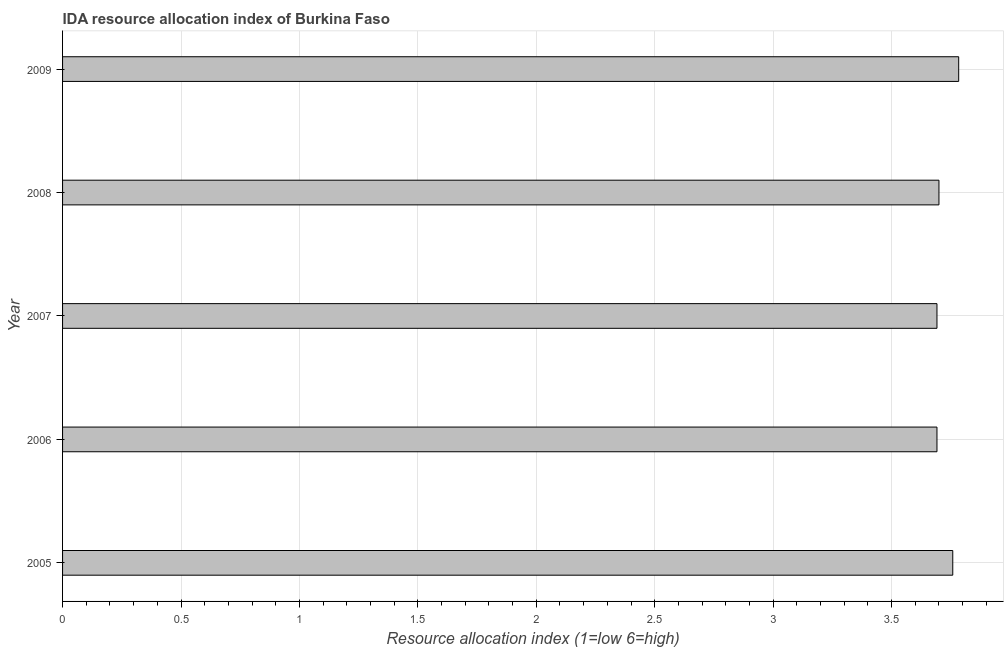Does the graph contain any zero values?
Ensure brevity in your answer.  No. What is the title of the graph?
Make the answer very short. IDA resource allocation index of Burkina Faso. What is the label or title of the X-axis?
Your response must be concise. Resource allocation index (1=low 6=high). What is the ida resource allocation index in 2008?
Keep it short and to the point. 3.7. Across all years, what is the maximum ida resource allocation index?
Offer a terse response. 3.78. Across all years, what is the minimum ida resource allocation index?
Give a very brief answer. 3.69. In which year was the ida resource allocation index minimum?
Your answer should be compact. 2006. What is the sum of the ida resource allocation index?
Give a very brief answer. 18.62. What is the difference between the ida resource allocation index in 2008 and 2009?
Provide a succinct answer. -0.08. What is the average ida resource allocation index per year?
Make the answer very short. 3.73. Do a majority of the years between 2008 and 2007 (inclusive) have ida resource allocation index greater than 3.7 ?
Your response must be concise. No. Is the ida resource allocation index in 2005 less than that in 2007?
Provide a succinct answer. No. Is the difference between the ida resource allocation index in 2006 and 2007 greater than the difference between any two years?
Provide a succinct answer. No. What is the difference between the highest and the second highest ida resource allocation index?
Make the answer very short. 0.03. Is the sum of the ida resource allocation index in 2007 and 2009 greater than the maximum ida resource allocation index across all years?
Your response must be concise. Yes. What is the difference between the highest and the lowest ida resource allocation index?
Provide a short and direct response. 0.09. In how many years, is the ida resource allocation index greater than the average ida resource allocation index taken over all years?
Ensure brevity in your answer.  2. What is the difference between two consecutive major ticks on the X-axis?
Your answer should be very brief. 0.5. Are the values on the major ticks of X-axis written in scientific E-notation?
Provide a succinct answer. No. What is the Resource allocation index (1=low 6=high) in 2005?
Your answer should be compact. 3.76. What is the Resource allocation index (1=low 6=high) of 2006?
Offer a terse response. 3.69. What is the Resource allocation index (1=low 6=high) in 2007?
Your answer should be very brief. 3.69. What is the Resource allocation index (1=low 6=high) in 2008?
Your response must be concise. 3.7. What is the Resource allocation index (1=low 6=high) in 2009?
Offer a terse response. 3.78. What is the difference between the Resource allocation index (1=low 6=high) in 2005 and 2006?
Your answer should be very brief. 0.07. What is the difference between the Resource allocation index (1=low 6=high) in 2005 and 2007?
Ensure brevity in your answer.  0.07. What is the difference between the Resource allocation index (1=low 6=high) in 2005 and 2008?
Make the answer very short. 0.06. What is the difference between the Resource allocation index (1=low 6=high) in 2005 and 2009?
Your response must be concise. -0.03. What is the difference between the Resource allocation index (1=low 6=high) in 2006 and 2008?
Provide a short and direct response. -0.01. What is the difference between the Resource allocation index (1=low 6=high) in 2006 and 2009?
Your answer should be compact. -0.09. What is the difference between the Resource allocation index (1=low 6=high) in 2007 and 2008?
Your answer should be compact. -0.01. What is the difference between the Resource allocation index (1=low 6=high) in 2007 and 2009?
Your response must be concise. -0.09. What is the difference between the Resource allocation index (1=low 6=high) in 2008 and 2009?
Offer a terse response. -0.08. What is the ratio of the Resource allocation index (1=low 6=high) in 2005 to that in 2009?
Provide a short and direct response. 0.99. What is the ratio of the Resource allocation index (1=low 6=high) in 2006 to that in 2008?
Your answer should be very brief. 1. What is the ratio of the Resource allocation index (1=low 6=high) in 2006 to that in 2009?
Make the answer very short. 0.98. What is the ratio of the Resource allocation index (1=low 6=high) in 2007 to that in 2008?
Ensure brevity in your answer.  1. What is the ratio of the Resource allocation index (1=low 6=high) in 2007 to that in 2009?
Make the answer very short. 0.98. What is the ratio of the Resource allocation index (1=low 6=high) in 2008 to that in 2009?
Provide a succinct answer. 0.98. 